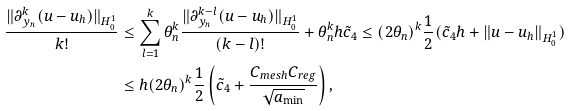<formula> <loc_0><loc_0><loc_500><loc_500>\frac { \| \partial _ { y _ { n } } ^ { k } ( u - u _ { h } ) \| _ { H ^ { 1 } _ { 0 } } } { k ! } & \leq \sum _ { l = 1 } ^ { k } \theta _ { n } ^ { k } \frac { \| \partial _ { y _ { n } } ^ { k - l } ( u - u _ { h } ) \| _ { H _ { 0 } ^ { 1 } } } { ( k - l ) ! } + \theta _ { n } ^ { k } h \tilde { c } _ { 4 } \leq ( 2 \theta _ { n } ) ^ { k } \frac { 1 } { 2 } ( \tilde { c } _ { 4 } h + \| u - u _ { h } \| _ { H _ { 0 } ^ { 1 } } ) \\ & \leq h ( 2 \theta _ { n } ) ^ { k } \frac { 1 } { 2 } \left ( \tilde { c } _ { 4 } + \frac { C _ { m e s h } C _ { r e g } } { \sqrt { a _ { \min } } } \right ) ,</formula> 